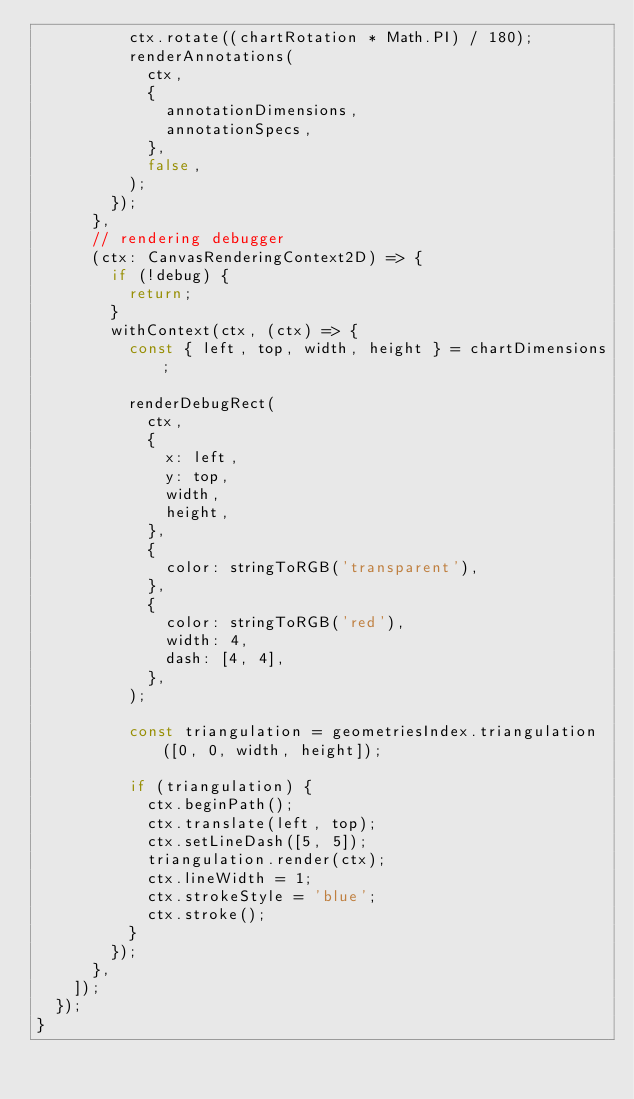Convert code to text. <code><loc_0><loc_0><loc_500><loc_500><_TypeScript_>          ctx.rotate((chartRotation * Math.PI) / 180);
          renderAnnotations(
            ctx,
            {
              annotationDimensions,
              annotationSpecs,
            },
            false,
          );
        });
      },
      // rendering debugger
      (ctx: CanvasRenderingContext2D) => {
        if (!debug) {
          return;
        }
        withContext(ctx, (ctx) => {
          const { left, top, width, height } = chartDimensions;

          renderDebugRect(
            ctx,
            {
              x: left,
              y: top,
              width,
              height,
            },
            {
              color: stringToRGB('transparent'),
            },
            {
              color: stringToRGB('red'),
              width: 4,
              dash: [4, 4],
            },
          );

          const triangulation = geometriesIndex.triangulation([0, 0, width, height]);

          if (triangulation) {
            ctx.beginPath();
            ctx.translate(left, top);
            ctx.setLineDash([5, 5]);
            triangulation.render(ctx);
            ctx.lineWidth = 1;
            ctx.strokeStyle = 'blue';
            ctx.stroke();
          }
        });
      },
    ]);
  });
}
</code> 